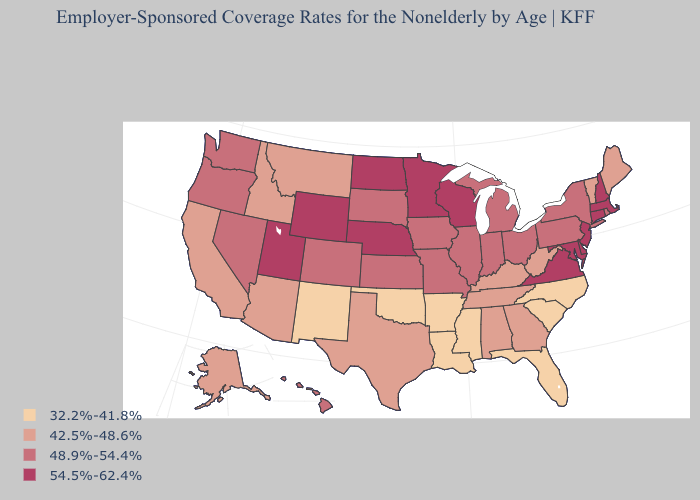How many symbols are there in the legend?
Answer briefly. 4. Which states have the highest value in the USA?
Short answer required. Connecticut, Delaware, Maryland, Massachusetts, Minnesota, Nebraska, New Hampshire, New Jersey, North Dakota, Utah, Virginia, Wisconsin, Wyoming. What is the highest value in the Northeast ?
Short answer required. 54.5%-62.4%. Which states have the lowest value in the South?
Give a very brief answer. Arkansas, Florida, Louisiana, Mississippi, North Carolina, Oklahoma, South Carolina. Name the states that have a value in the range 42.5%-48.6%?
Answer briefly. Alabama, Alaska, Arizona, California, Georgia, Idaho, Kentucky, Maine, Montana, Tennessee, Texas, Vermont, West Virginia. Name the states that have a value in the range 48.9%-54.4%?
Keep it brief. Colorado, Hawaii, Illinois, Indiana, Iowa, Kansas, Michigan, Missouri, Nevada, New York, Ohio, Oregon, Pennsylvania, Rhode Island, South Dakota, Washington. What is the lowest value in the West?
Be succinct. 32.2%-41.8%. Name the states that have a value in the range 42.5%-48.6%?
Keep it brief. Alabama, Alaska, Arizona, California, Georgia, Idaho, Kentucky, Maine, Montana, Tennessee, Texas, Vermont, West Virginia. Among the states that border Arizona , does Nevada have the lowest value?
Short answer required. No. How many symbols are there in the legend?
Quick response, please. 4. Does Massachusetts have a higher value than Virginia?
Be succinct. No. Which states have the lowest value in the West?
Be succinct. New Mexico. Does Mississippi have a higher value than Massachusetts?
Quick response, please. No. Among the states that border Wyoming , which have the highest value?
Be succinct. Nebraska, Utah. Does the first symbol in the legend represent the smallest category?
Answer briefly. Yes. 